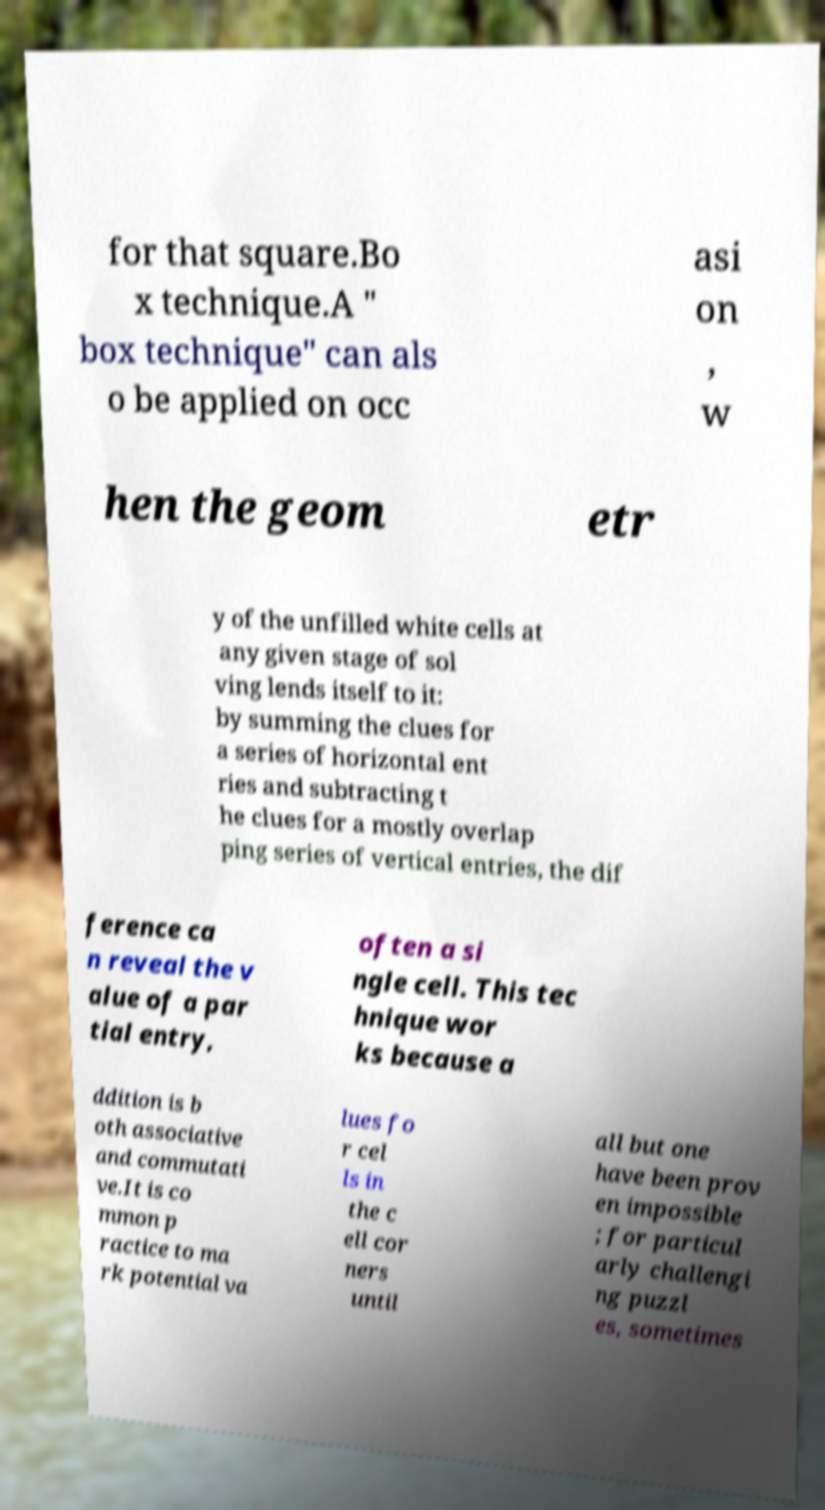Could you assist in decoding the text presented in this image and type it out clearly? for that square.Bo x technique.A " box technique" can als o be applied on occ asi on , w hen the geom etr y of the unfilled white cells at any given stage of sol ving lends itself to it: by summing the clues for a series of horizontal ent ries and subtracting t he clues for a mostly overlap ping series of vertical entries, the dif ference ca n reveal the v alue of a par tial entry, often a si ngle cell. This tec hnique wor ks because a ddition is b oth associative and commutati ve.It is co mmon p ractice to ma rk potential va lues fo r cel ls in the c ell cor ners until all but one have been prov en impossible ; for particul arly challengi ng puzzl es, sometimes 